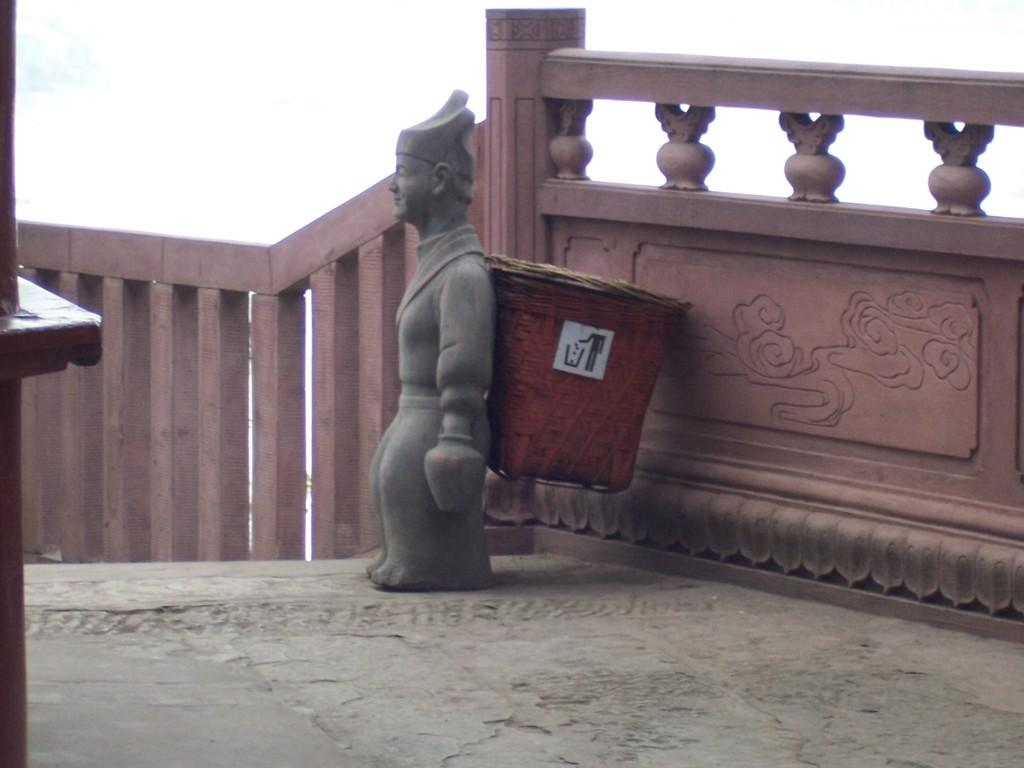What is one of the main objects in the image? There is a wall in the image. What is attached to the wall? There is a dustbin in the image, and it is attached to a sculpture. What is the name of the pan that is hanging on the wall in the image? There is no pan present in the image; it features a wall, a dustbin, and a sculpture. 